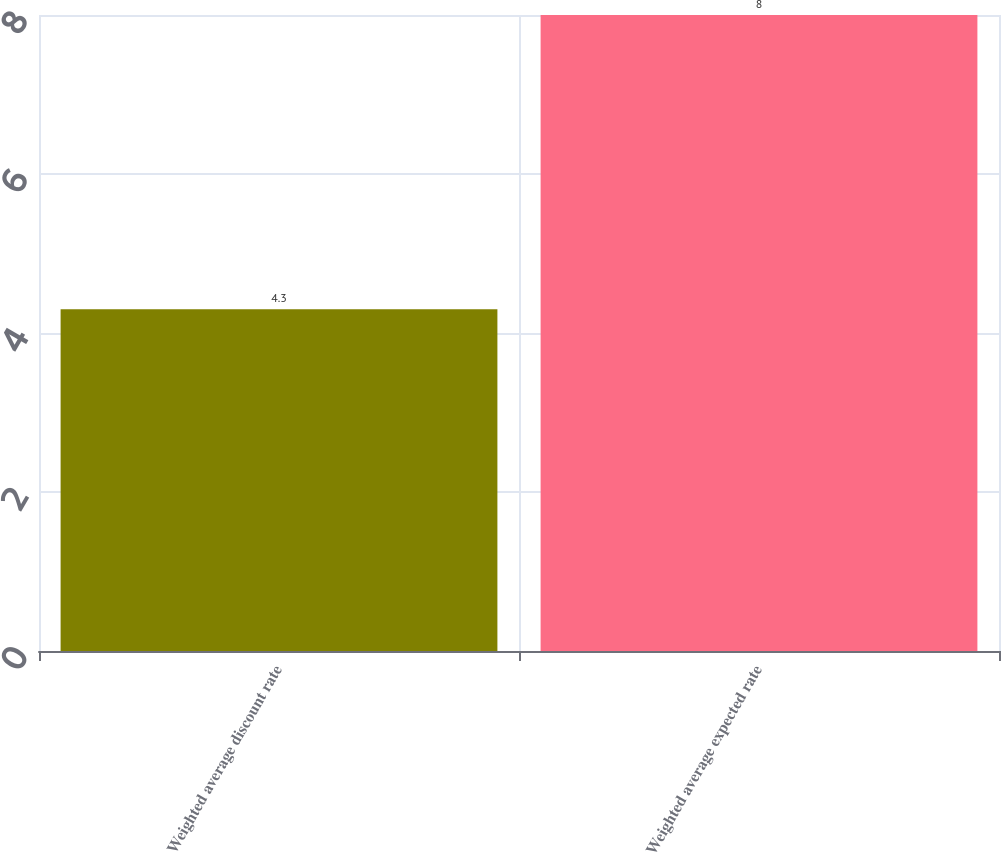Convert chart. <chart><loc_0><loc_0><loc_500><loc_500><bar_chart><fcel>Weighted average discount rate<fcel>Weighted average expected rate<nl><fcel>4.3<fcel>8<nl></chart> 